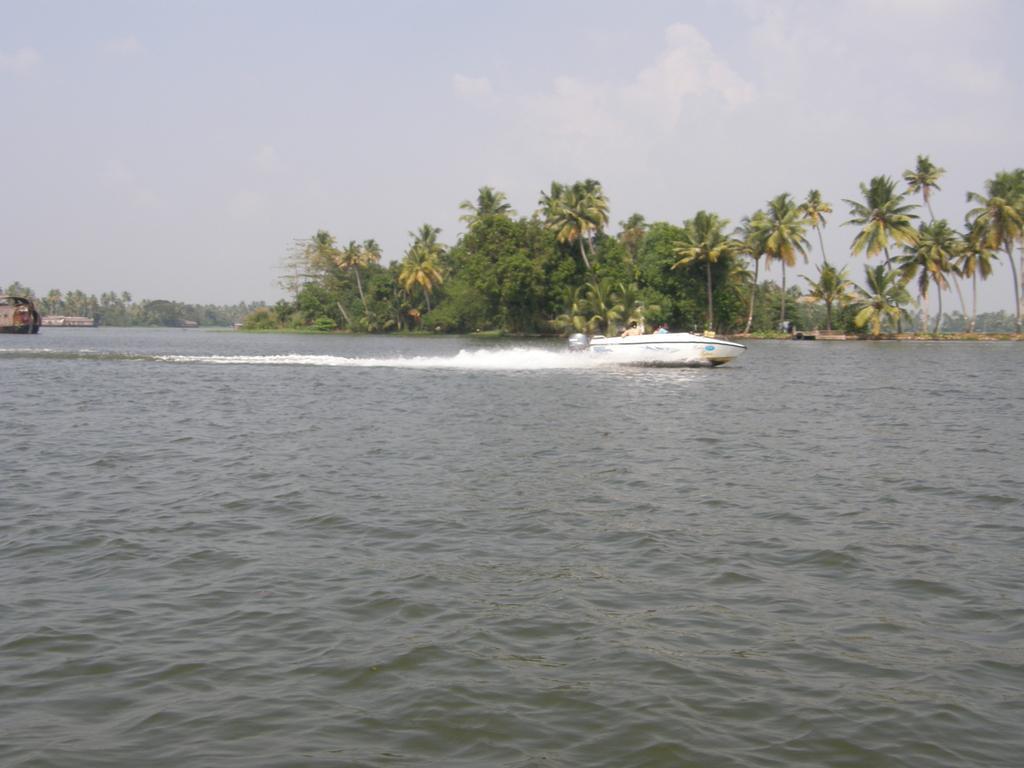Could you give a brief overview of what you see in this image? In this image I see the water and I see a white color boat over here and in the background I see the trees and the clear and I see a brown color thing over here. 